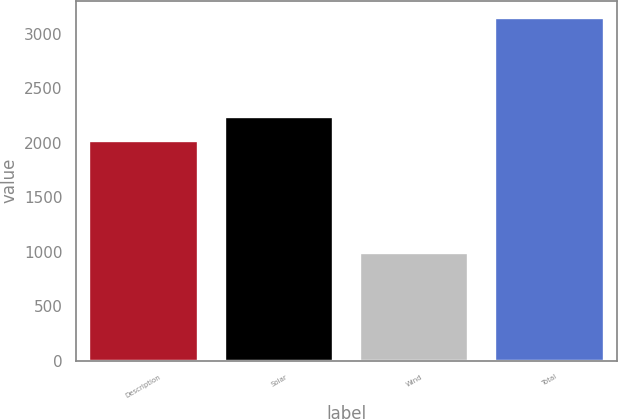Convert chart. <chart><loc_0><loc_0><loc_500><loc_500><bar_chart><fcel>Description<fcel>Solar<fcel>Wind<fcel>Total<nl><fcel>2017<fcel>2232.8<fcel>988<fcel>3146<nl></chart> 